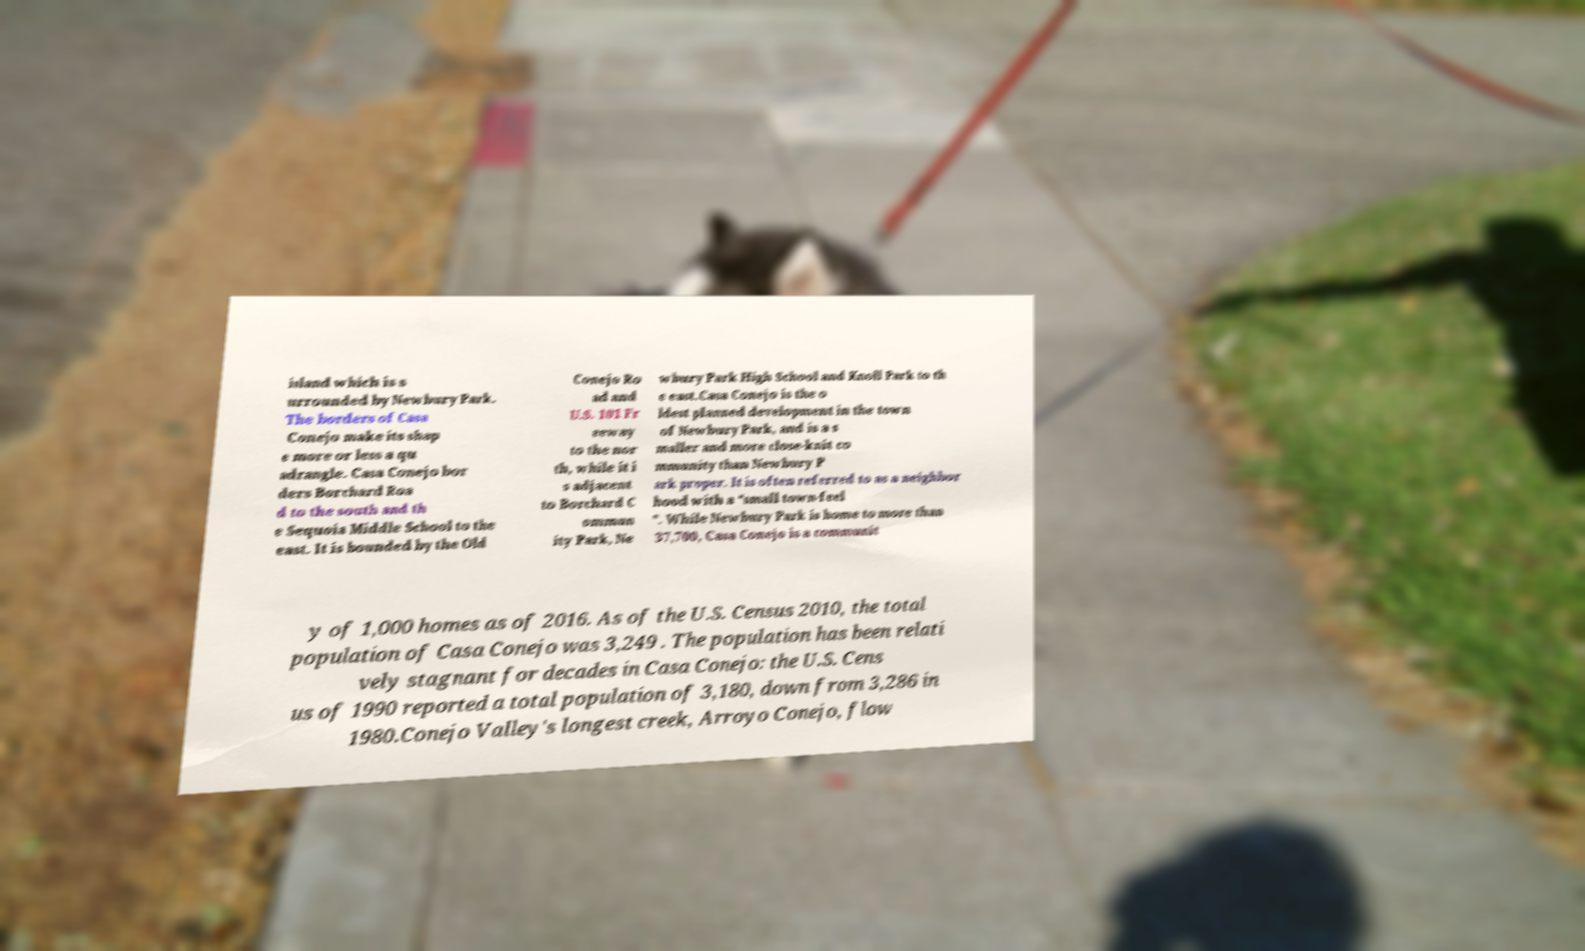Can you read and provide the text displayed in the image?This photo seems to have some interesting text. Can you extract and type it out for me? island which is s urrounded by Newbury Park. The borders of Casa Conejo make its shap e more or less a qu adrangle. Casa Conejo bor ders Borchard Roa d to the south and th e Sequoia Middle School to the east. It is bounded by the Old Conejo Ro ad and U.S. 101 Fr eeway to the nor th, while it i s adjacent to Borchard C ommun ity Park, Ne wbury Park High School and Knoll Park to th e east.Casa Conejo is the o ldest planned development in the town of Newbury Park, and is a s maller and more close-knit co mmunity than Newbury P ark proper. It is often referred to as a neighbor hood with a “small town-feel ”. While Newbury Park is home to more than 37,700, Casa Conejo is a communit y of 1,000 homes as of 2016. As of the U.S. Census 2010, the total population of Casa Conejo was 3,249 . The population has been relati vely stagnant for decades in Casa Conejo: the U.S. Cens us of 1990 reported a total population of 3,180, down from 3,286 in 1980.Conejo Valley's longest creek, Arroyo Conejo, flow 